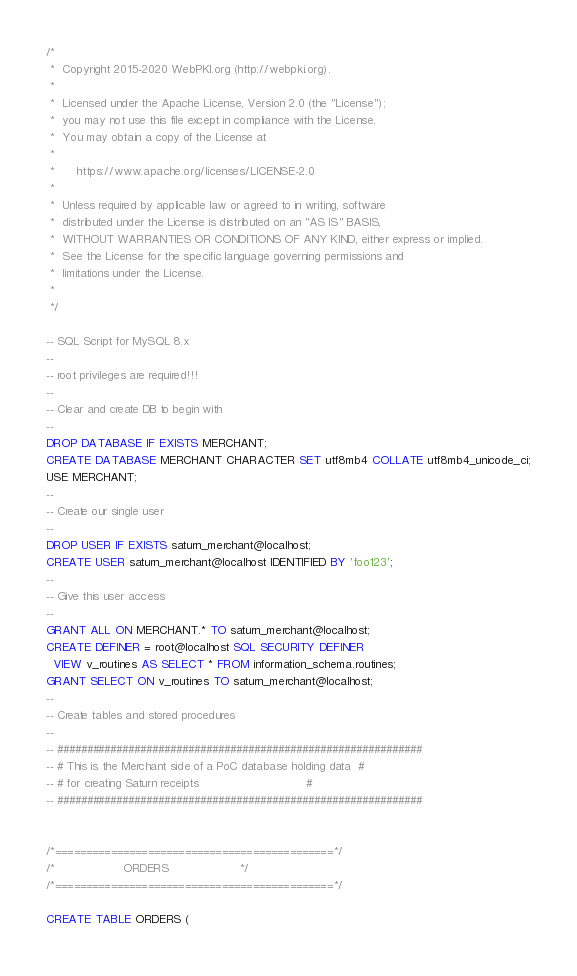Convert code to text. <code><loc_0><loc_0><loc_500><loc_500><_SQL_>/*
 *  Copyright 2015-2020 WebPKI.org (http://webpki.org).
 *
 *  Licensed under the Apache License, Version 2.0 (the "License");
 *  you may not use this file except in compliance with the License.
 *  You may obtain a copy of the License at
 *
 *      https://www.apache.org/licenses/LICENSE-2.0
 *
 *  Unless required by applicable law or agreed to in writing, software
 *  distributed under the License is distributed on an "AS IS" BASIS,
 *  WITHOUT WARRANTIES OR CONDITIONS OF ANY KIND, either express or implied.
 *  See the License for the specific language governing permissions and
 *  limitations under the License.
 *
 */

-- SQL Script for MySQL 8.x
--
-- root privileges are required!!!
--
-- Clear and create DB to begin with
--
DROP DATABASE IF EXISTS MERCHANT;
CREATE DATABASE MERCHANT CHARACTER SET utf8mb4 COLLATE utf8mb4_unicode_ci;
USE MERCHANT;
--
-- Create our single user
--
DROP USER IF EXISTS saturn_merchant@localhost;
CREATE USER saturn_merchant@localhost IDENTIFIED BY 'foo123';
--
-- Give this user access
--
GRANT ALL ON MERCHANT.* TO saturn_merchant@localhost;
CREATE DEFINER = root@localhost SQL SECURITY DEFINER
  VIEW v_routines AS SELECT * FROM information_schema.routines;
GRANT SELECT ON v_routines TO saturn_merchant@localhost;
--
-- Create tables and stored procedures
--
-- #############################################################
-- # This is the Merchant side of a PoC database holding data  #
-- # for creating Saturn receipts                              #
-- #############################################################


/*=============================================*/
/*                   ORDERS                    */
/*=============================================*/

CREATE TABLE ORDERS (</code> 